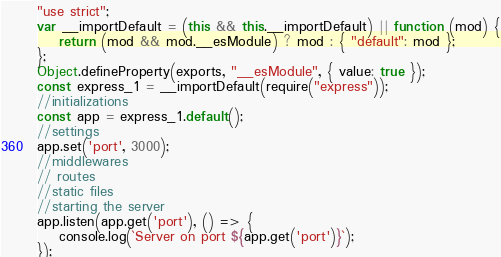<code> <loc_0><loc_0><loc_500><loc_500><_JavaScript_>"use strict";
var __importDefault = (this && this.__importDefault) || function (mod) {
    return (mod && mod.__esModule) ? mod : { "default": mod };
};
Object.defineProperty(exports, "__esModule", { value: true });
const express_1 = __importDefault(require("express"));
//initializations
const app = express_1.default();
//settings
app.set('port', 3000);
//middlewares
// routes
//static files
//starting the server
app.listen(app.get('port'), () => {
    console.log(`Server on port ${app.get('port')}`);
});
</code> 